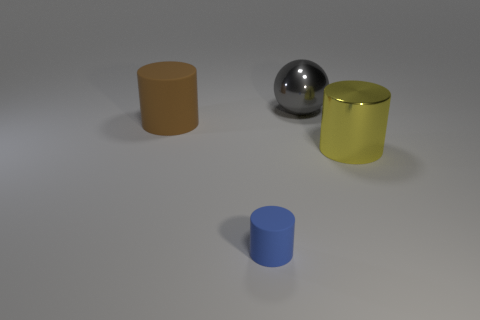Is there any other thing that is the same size as the blue rubber thing?
Provide a short and direct response. No. What number of cyan objects are either large spheres or cylinders?
Your answer should be compact. 0. What number of other objects are the same shape as the big rubber object?
Your response must be concise. 2. Do the tiny object and the brown cylinder have the same material?
Your response must be concise. Yes. What is the material of the cylinder that is both left of the gray metallic ball and in front of the brown rubber cylinder?
Offer a terse response. Rubber. There is a cylinder behind the large shiny cylinder; what color is it?
Make the answer very short. Brown. Is the number of blue matte cylinders in front of the big gray metal thing greater than the number of tiny gray metal cylinders?
Offer a very short reply. Yes. What number of other things are the same size as the brown rubber cylinder?
Your answer should be compact. 2. There is a small rubber thing; how many gray shiny spheres are behind it?
Offer a very short reply. 1. Are there an equal number of shiny balls left of the tiny blue rubber object and gray shiny spheres that are to the left of the gray metal object?
Offer a terse response. Yes. 